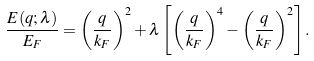<formula> <loc_0><loc_0><loc_500><loc_500>\frac { E ( q ; \lambda ) } { E _ { F } } = \left ( \frac { q } { k _ { F } } \right ) ^ { 2 } + \lambda \left [ \left ( \frac { q } { k _ { F } } \right ) ^ { 4 } - \left ( \frac { q } { k _ { F } } \right ) ^ { 2 } \right ] .</formula> 